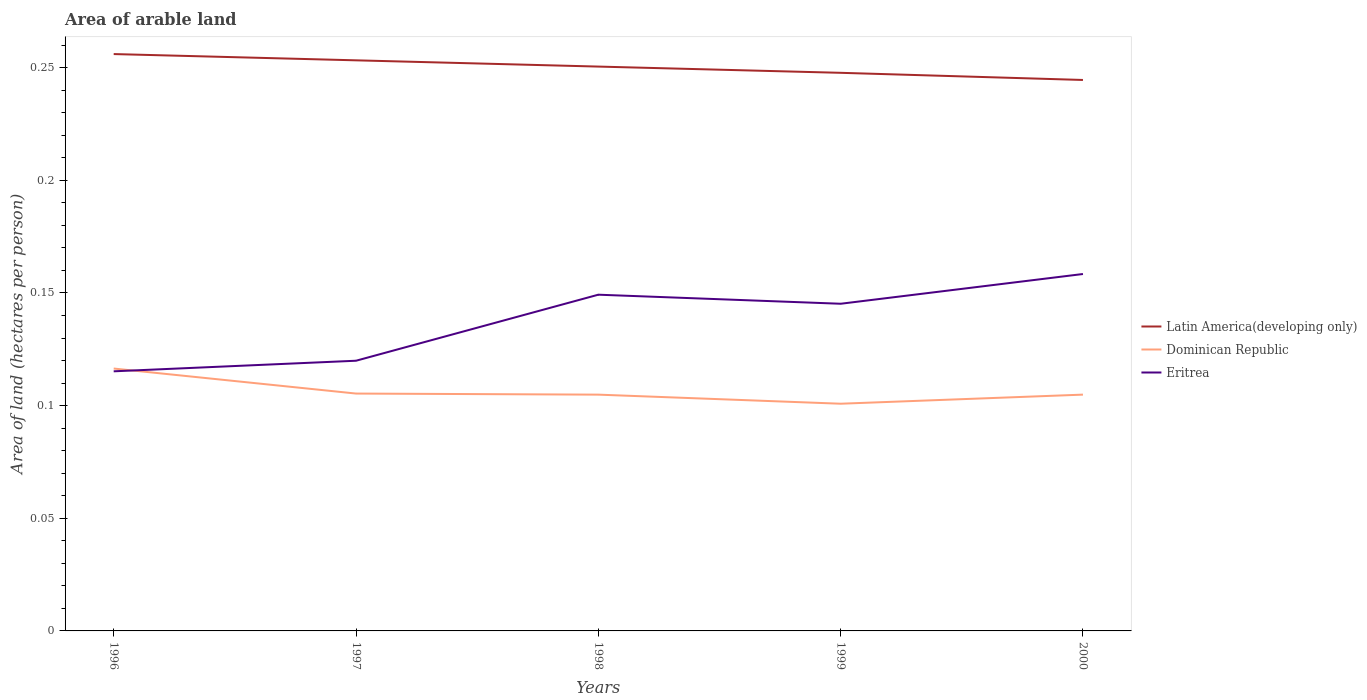Does the line corresponding to Latin America(developing only) intersect with the line corresponding to Dominican Republic?
Your response must be concise. No. Is the number of lines equal to the number of legend labels?
Your answer should be compact. Yes. Across all years, what is the maximum total arable land in Eritrea?
Offer a terse response. 0.12. What is the total total arable land in Eritrea in the graph?
Give a very brief answer. -0.04. What is the difference between the highest and the second highest total arable land in Eritrea?
Make the answer very short. 0.04. What is the difference between the highest and the lowest total arable land in Latin America(developing only)?
Your answer should be compact. 3. Are the values on the major ticks of Y-axis written in scientific E-notation?
Your answer should be compact. No. How many legend labels are there?
Provide a succinct answer. 3. How are the legend labels stacked?
Your answer should be very brief. Vertical. What is the title of the graph?
Provide a succinct answer. Area of arable land. What is the label or title of the Y-axis?
Ensure brevity in your answer.  Area of land (hectares per person). What is the Area of land (hectares per person) in Latin America(developing only) in 1996?
Your response must be concise. 0.26. What is the Area of land (hectares per person) in Dominican Republic in 1996?
Your answer should be very brief. 0.12. What is the Area of land (hectares per person) of Eritrea in 1996?
Keep it short and to the point. 0.12. What is the Area of land (hectares per person) in Latin America(developing only) in 1997?
Give a very brief answer. 0.25. What is the Area of land (hectares per person) of Dominican Republic in 1997?
Make the answer very short. 0.11. What is the Area of land (hectares per person) of Eritrea in 1997?
Offer a terse response. 0.12. What is the Area of land (hectares per person) of Latin America(developing only) in 1998?
Offer a terse response. 0.25. What is the Area of land (hectares per person) of Dominican Republic in 1998?
Ensure brevity in your answer.  0.1. What is the Area of land (hectares per person) of Eritrea in 1998?
Offer a very short reply. 0.15. What is the Area of land (hectares per person) of Latin America(developing only) in 1999?
Keep it short and to the point. 0.25. What is the Area of land (hectares per person) in Dominican Republic in 1999?
Offer a very short reply. 0.1. What is the Area of land (hectares per person) of Eritrea in 1999?
Keep it short and to the point. 0.15. What is the Area of land (hectares per person) of Latin America(developing only) in 2000?
Give a very brief answer. 0.24. What is the Area of land (hectares per person) of Dominican Republic in 2000?
Your answer should be very brief. 0.1. What is the Area of land (hectares per person) of Eritrea in 2000?
Provide a succinct answer. 0.16. Across all years, what is the maximum Area of land (hectares per person) in Latin America(developing only)?
Provide a short and direct response. 0.26. Across all years, what is the maximum Area of land (hectares per person) of Dominican Republic?
Provide a succinct answer. 0.12. Across all years, what is the maximum Area of land (hectares per person) of Eritrea?
Keep it short and to the point. 0.16. Across all years, what is the minimum Area of land (hectares per person) in Latin America(developing only)?
Ensure brevity in your answer.  0.24. Across all years, what is the minimum Area of land (hectares per person) of Dominican Republic?
Offer a terse response. 0.1. Across all years, what is the minimum Area of land (hectares per person) in Eritrea?
Keep it short and to the point. 0.12. What is the total Area of land (hectares per person) in Latin America(developing only) in the graph?
Provide a succinct answer. 1.25. What is the total Area of land (hectares per person) of Dominican Republic in the graph?
Offer a terse response. 0.53. What is the total Area of land (hectares per person) of Eritrea in the graph?
Provide a succinct answer. 0.69. What is the difference between the Area of land (hectares per person) in Latin America(developing only) in 1996 and that in 1997?
Give a very brief answer. 0. What is the difference between the Area of land (hectares per person) in Dominican Republic in 1996 and that in 1997?
Provide a succinct answer. 0.01. What is the difference between the Area of land (hectares per person) in Eritrea in 1996 and that in 1997?
Ensure brevity in your answer.  -0. What is the difference between the Area of land (hectares per person) in Latin America(developing only) in 1996 and that in 1998?
Your answer should be compact. 0.01. What is the difference between the Area of land (hectares per person) of Dominican Republic in 1996 and that in 1998?
Provide a short and direct response. 0.01. What is the difference between the Area of land (hectares per person) in Eritrea in 1996 and that in 1998?
Offer a very short reply. -0.03. What is the difference between the Area of land (hectares per person) of Latin America(developing only) in 1996 and that in 1999?
Your response must be concise. 0.01. What is the difference between the Area of land (hectares per person) of Dominican Republic in 1996 and that in 1999?
Your response must be concise. 0.02. What is the difference between the Area of land (hectares per person) of Eritrea in 1996 and that in 1999?
Provide a succinct answer. -0.03. What is the difference between the Area of land (hectares per person) in Latin America(developing only) in 1996 and that in 2000?
Offer a terse response. 0.01. What is the difference between the Area of land (hectares per person) in Dominican Republic in 1996 and that in 2000?
Offer a terse response. 0.01. What is the difference between the Area of land (hectares per person) of Eritrea in 1996 and that in 2000?
Your answer should be compact. -0.04. What is the difference between the Area of land (hectares per person) in Latin America(developing only) in 1997 and that in 1998?
Offer a very short reply. 0. What is the difference between the Area of land (hectares per person) in Eritrea in 1997 and that in 1998?
Give a very brief answer. -0.03. What is the difference between the Area of land (hectares per person) in Latin America(developing only) in 1997 and that in 1999?
Give a very brief answer. 0.01. What is the difference between the Area of land (hectares per person) in Dominican Republic in 1997 and that in 1999?
Ensure brevity in your answer.  0. What is the difference between the Area of land (hectares per person) of Eritrea in 1997 and that in 1999?
Give a very brief answer. -0.03. What is the difference between the Area of land (hectares per person) of Latin America(developing only) in 1997 and that in 2000?
Keep it short and to the point. 0.01. What is the difference between the Area of land (hectares per person) of Dominican Republic in 1997 and that in 2000?
Ensure brevity in your answer.  0. What is the difference between the Area of land (hectares per person) in Eritrea in 1997 and that in 2000?
Offer a terse response. -0.04. What is the difference between the Area of land (hectares per person) in Latin America(developing only) in 1998 and that in 1999?
Ensure brevity in your answer.  0. What is the difference between the Area of land (hectares per person) of Dominican Republic in 1998 and that in 1999?
Your answer should be compact. 0. What is the difference between the Area of land (hectares per person) in Eritrea in 1998 and that in 1999?
Offer a terse response. 0. What is the difference between the Area of land (hectares per person) of Latin America(developing only) in 1998 and that in 2000?
Ensure brevity in your answer.  0.01. What is the difference between the Area of land (hectares per person) of Eritrea in 1998 and that in 2000?
Offer a terse response. -0.01. What is the difference between the Area of land (hectares per person) in Latin America(developing only) in 1999 and that in 2000?
Give a very brief answer. 0. What is the difference between the Area of land (hectares per person) of Dominican Republic in 1999 and that in 2000?
Your answer should be very brief. -0. What is the difference between the Area of land (hectares per person) in Eritrea in 1999 and that in 2000?
Provide a short and direct response. -0.01. What is the difference between the Area of land (hectares per person) in Latin America(developing only) in 1996 and the Area of land (hectares per person) in Dominican Republic in 1997?
Offer a very short reply. 0.15. What is the difference between the Area of land (hectares per person) of Latin America(developing only) in 1996 and the Area of land (hectares per person) of Eritrea in 1997?
Provide a short and direct response. 0.14. What is the difference between the Area of land (hectares per person) of Dominican Republic in 1996 and the Area of land (hectares per person) of Eritrea in 1997?
Ensure brevity in your answer.  -0. What is the difference between the Area of land (hectares per person) of Latin America(developing only) in 1996 and the Area of land (hectares per person) of Dominican Republic in 1998?
Provide a short and direct response. 0.15. What is the difference between the Area of land (hectares per person) in Latin America(developing only) in 1996 and the Area of land (hectares per person) in Eritrea in 1998?
Make the answer very short. 0.11. What is the difference between the Area of land (hectares per person) in Dominican Republic in 1996 and the Area of land (hectares per person) in Eritrea in 1998?
Make the answer very short. -0.03. What is the difference between the Area of land (hectares per person) of Latin America(developing only) in 1996 and the Area of land (hectares per person) of Dominican Republic in 1999?
Provide a succinct answer. 0.16. What is the difference between the Area of land (hectares per person) in Latin America(developing only) in 1996 and the Area of land (hectares per person) in Eritrea in 1999?
Your answer should be very brief. 0.11. What is the difference between the Area of land (hectares per person) of Dominican Republic in 1996 and the Area of land (hectares per person) of Eritrea in 1999?
Offer a very short reply. -0.03. What is the difference between the Area of land (hectares per person) of Latin America(developing only) in 1996 and the Area of land (hectares per person) of Dominican Republic in 2000?
Offer a very short reply. 0.15. What is the difference between the Area of land (hectares per person) of Latin America(developing only) in 1996 and the Area of land (hectares per person) of Eritrea in 2000?
Give a very brief answer. 0.1. What is the difference between the Area of land (hectares per person) of Dominican Republic in 1996 and the Area of land (hectares per person) of Eritrea in 2000?
Keep it short and to the point. -0.04. What is the difference between the Area of land (hectares per person) in Latin America(developing only) in 1997 and the Area of land (hectares per person) in Dominican Republic in 1998?
Your response must be concise. 0.15. What is the difference between the Area of land (hectares per person) in Latin America(developing only) in 1997 and the Area of land (hectares per person) in Eritrea in 1998?
Provide a succinct answer. 0.1. What is the difference between the Area of land (hectares per person) in Dominican Republic in 1997 and the Area of land (hectares per person) in Eritrea in 1998?
Ensure brevity in your answer.  -0.04. What is the difference between the Area of land (hectares per person) of Latin America(developing only) in 1997 and the Area of land (hectares per person) of Dominican Republic in 1999?
Provide a short and direct response. 0.15. What is the difference between the Area of land (hectares per person) of Latin America(developing only) in 1997 and the Area of land (hectares per person) of Eritrea in 1999?
Offer a terse response. 0.11. What is the difference between the Area of land (hectares per person) in Dominican Republic in 1997 and the Area of land (hectares per person) in Eritrea in 1999?
Provide a short and direct response. -0.04. What is the difference between the Area of land (hectares per person) in Latin America(developing only) in 1997 and the Area of land (hectares per person) in Dominican Republic in 2000?
Offer a terse response. 0.15. What is the difference between the Area of land (hectares per person) in Latin America(developing only) in 1997 and the Area of land (hectares per person) in Eritrea in 2000?
Make the answer very short. 0.09. What is the difference between the Area of land (hectares per person) of Dominican Republic in 1997 and the Area of land (hectares per person) of Eritrea in 2000?
Your answer should be very brief. -0.05. What is the difference between the Area of land (hectares per person) in Latin America(developing only) in 1998 and the Area of land (hectares per person) in Dominican Republic in 1999?
Offer a terse response. 0.15. What is the difference between the Area of land (hectares per person) of Latin America(developing only) in 1998 and the Area of land (hectares per person) of Eritrea in 1999?
Make the answer very short. 0.11. What is the difference between the Area of land (hectares per person) in Dominican Republic in 1998 and the Area of land (hectares per person) in Eritrea in 1999?
Your answer should be very brief. -0.04. What is the difference between the Area of land (hectares per person) in Latin America(developing only) in 1998 and the Area of land (hectares per person) in Dominican Republic in 2000?
Your response must be concise. 0.15. What is the difference between the Area of land (hectares per person) of Latin America(developing only) in 1998 and the Area of land (hectares per person) of Eritrea in 2000?
Provide a succinct answer. 0.09. What is the difference between the Area of land (hectares per person) of Dominican Republic in 1998 and the Area of land (hectares per person) of Eritrea in 2000?
Your answer should be compact. -0.05. What is the difference between the Area of land (hectares per person) of Latin America(developing only) in 1999 and the Area of land (hectares per person) of Dominican Republic in 2000?
Your answer should be very brief. 0.14. What is the difference between the Area of land (hectares per person) of Latin America(developing only) in 1999 and the Area of land (hectares per person) of Eritrea in 2000?
Give a very brief answer. 0.09. What is the difference between the Area of land (hectares per person) of Dominican Republic in 1999 and the Area of land (hectares per person) of Eritrea in 2000?
Offer a terse response. -0.06. What is the average Area of land (hectares per person) in Latin America(developing only) per year?
Offer a terse response. 0.25. What is the average Area of land (hectares per person) in Dominican Republic per year?
Offer a very short reply. 0.11. What is the average Area of land (hectares per person) in Eritrea per year?
Provide a short and direct response. 0.14. In the year 1996, what is the difference between the Area of land (hectares per person) in Latin America(developing only) and Area of land (hectares per person) in Dominican Republic?
Provide a succinct answer. 0.14. In the year 1996, what is the difference between the Area of land (hectares per person) of Latin America(developing only) and Area of land (hectares per person) of Eritrea?
Your answer should be very brief. 0.14. In the year 1996, what is the difference between the Area of land (hectares per person) in Dominican Republic and Area of land (hectares per person) in Eritrea?
Give a very brief answer. 0. In the year 1997, what is the difference between the Area of land (hectares per person) in Latin America(developing only) and Area of land (hectares per person) in Dominican Republic?
Your answer should be compact. 0.15. In the year 1997, what is the difference between the Area of land (hectares per person) in Latin America(developing only) and Area of land (hectares per person) in Eritrea?
Offer a very short reply. 0.13. In the year 1997, what is the difference between the Area of land (hectares per person) of Dominican Republic and Area of land (hectares per person) of Eritrea?
Offer a very short reply. -0.01. In the year 1998, what is the difference between the Area of land (hectares per person) in Latin America(developing only) and Area of land (hectares per person) in Dominican Republic?
Provide a short and direct response. 0.15. In the year 1998, what is the difference between the Area of land (hectares per person) in Latin America(developing only) and Area of land (hectares per person) in Eritrea?
Keep it short and to the point. 0.1. In the year 1998, what is the difference between the Area of land (hectares per person) of Dominican Republic and Area of land (hectares per person) of Eritrea?
Keep it short and to the point. -0.04. In the year 1999, what is the difference between the Area of land (hectares per person) of Latin America(developing only) and Area of land (hectares per person) of Dominican Republic?
Offer a terse response. 0.15. In the year 1999, what is the difference between the Area of land (hectares per person) in Latin America(developing only) and Area of land (hectares per person) in Eritrea?
Provide a succinct answer. 0.1. In the year 1999, what is the difference between the Area of land (hectares per person) of Dominican Republic and Area of land (hectares per person) of Eritrea?
Give a very brief answer. -0.04. In the year 2000, what is the difference between the Area of land (hectares per person) of Latin America(developing only) and Area of land (hectares per person) of Dominican Republic?
Your response must be concise. 0.14. In the year 2000, what is the difference between the Area of land (hectares per person) in Latin America(developing only) and Area of land (hectares per person) in Eritrea?
Make the answer very short. 0.09. In the year 2000, what is the difference between the Area of land (hectares per person) of Dominican Republic and Area of land (hectares per person) of Eritrea?
Your answer should be compact. -0.05. What is the ratio of the Area of land (hectares per person) in Dominican Republic in 1996 to that in 1997?
Ensure brevity in your answer.  1.11. What is the ratio of the Area of land (hectares per person) of Eritrea in 1996 to that in 1997?
Your answer should be compact. 0.96. What is the ratio of the Area of land (hectares per person) of Latin America(developing only) in 1996 to that in 1998?
Offer a very short reply. 1.02. What is the ratio of the Area of land (hectares per person) in Dominican Republic in 1996 to that in 1998?
Ensure brevity in your answer.  1.11. What is the ratio of the Area of land (hectares per person) in Eritrea in 1996 to that in 1998?
Keep it short and to the point. 0.77. What is the ratio of the Area of land (hectares per person) in Latin America(developing only) in 1996 to that in 1999?
Ensure brevity in your answer.  1.03. What is the ratio of the Area of land (hectares per person) of Dominican Republic in 1996 to that in 1999?
Offer a terse response. 1.15. What is the ratio of the Area of land (hectares per person) of Eritrea in 1996 to that in 1999?
Keep it short and to the point. 0.79. What is the ratio of the Area of land (hectares per person) in Latin America(developing only) in 1996 to that in 2000?
Your answer should be compact. 1.05. What is the ratio of the Area of land (hectares per person) in Dominican Republic in 1996 to that in 2000?
Provide a succinct answer. 1.11. What is the ratio of the Area of land (hectares per person) in Eritrea in 1996 to that in 2000?
Your response must be concise. 0.73. What is the ratio of the Area of land (hectares per person) in Latin America(developing only) in 1997 to that in 1998?
Give a very brief answer. 1.01. What is the ratio of the Area of land (hectares per person) of Dominican Republic in 1997 to that in 1998?
Make the answer very short. 1. What is the ratio of the Area of land (hectares per person) in Eritrea in 1997 to that in 1998?
Make the answer very short. 0.8. What is the ratio of the Area of land (hectares per person) of Latin America(developing only) in 1997 to that in 1999?
Your answer should be very brief. 1.02. What is the ratio of the Area of land (hectares per person) in Dominican Republic in 1997 to that in 1999?
Your response must be concise. 1.04. What is the ratio of the Area of land (hectares per person) of Eritrea in 1997 to that in 1999?
Provide a succinct answer. 0.83. What is the ratio of the Area of land (hectares per person) of Latin America(developing only) in 1997 to that in 2000?
Make the answer very short. 1.04. What is the ratio of the Area of land (hectares per person) of Dominican Republic in 1997 to that in 2000?
Offer a very short reply. 1. What is the ratio of the Area of land (hectares per person) of Eritrea in 1997 to that in 2000?
Offer a terse response. 0.76. What is the ratio of the Area of land (hectares per person) in Latin America(developing only) in 1998 to that in 1999?
Give a very brief answer. 1.01. What is the ratio of the Area of land (hectares per person) in Dominican Republic in 1998 to that in 1999?
Make the answer very short. 1.04. What is the ratio of the Area of land (hectares per person) of Eritrea in 1998 to that in 1999?
Give a very brief answer. 1.03. What is the ratio of the Area of land (hectares per person) of Latin America(developing only) in 1998 to that in 2000?
Your answer should be very brief. 1.02. What is the ratio of the Area of land (hectares per person) in Eritrea in 1998 to that in 2000?
Your response must be concise. 0.94. What is the ratio of the Area of land (hectares per person) of Latin America(developing only) in 1999 to that in 2000?
Keep it short and to the point. 1.01. What is the ratio of the Area of land (hectares per person) in Dominican Republic in 1999 to that in 2000?
Provide a short and direct response. 0.96. What is the ratio of the Area of land (hectares per person) of Eritrea in 1999 to that in 2000?
Provide a short and direct response. 0.92. What is the difference between the highest and the second highest Area of land (hectares per person) in Latin America(developing only)?
Your response must be concise. 0. What is the difference between the highest and the second highest Area of land (hectares per person) of Dominican Republic?
Keep it short and to the point. 0.01. What is the difference between the highest and the second highest Area of land (hectares per person) in Eritrea?
Make the answer very short. 0.01. What is the difference between the highest and the lowest Area of land (hectares per person) of Latin America(developing only)?
Keep it short and to the point. 0.01. What is the difference between the highest and the lowest Area of land (hectares per person) of Dominican Republic?
Provide a succinct answer. 0.02. What is the difference between the highest and the lowest Area of land (hectares per person) of Eritrea?
Provide a short and direct response. 0.04. 